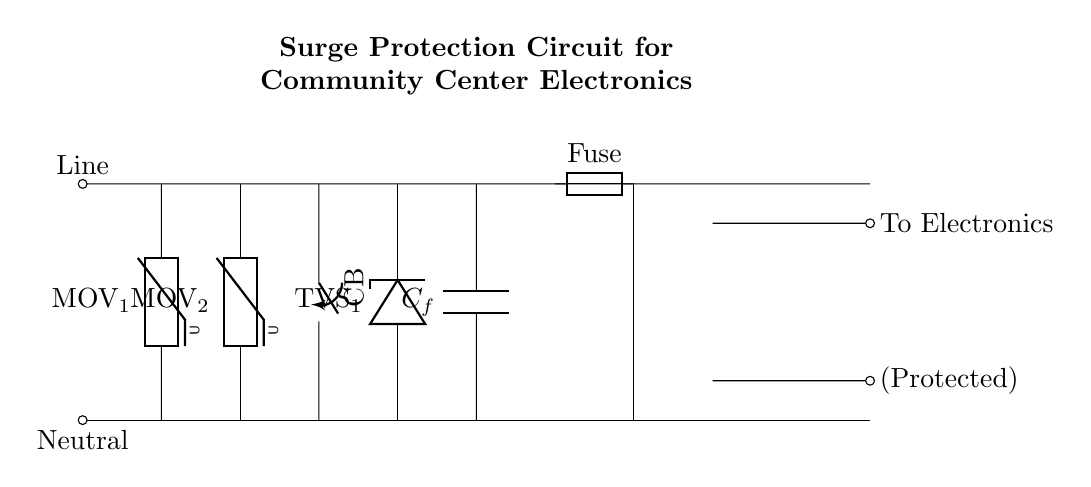What type of surge protection component is used in this circuit? The circuit uses Metal Oxide Varistors (MOVs) for surge protection, visible as MOV_1 and MOV_2 in the diagram.
Answer: Metal Oxide Varistors How many varistors are present in the circuit? There are two varistors, indicated as MOV_1 and MOV_2, shown connected to the power line.
Answer: Two What does CB stand for in this circuit? CB stands for Circuit Breaker, which is a switch placed in the circuit to protect against overloads and short circuits.
Answer: Circuit Breaker What is the purpose of the fuse in this circuit? The fuse serves as a protective device that disconnects the circuit when excessive current flows, preventing damage to the components.
Answer: Disconnects excessive current Which component directly protects against voltage transients? The TVS diode, labeled as TVS_1, is specifically designed to protect against voltage transients by clamping the excess voltage.
Answer: TVS diode How does the transformer function in this circuit? The transformer, shown as a transformer core, steps up or steps down voltage levels, providing appropriate voltage to the protected devices.
Answer: Steps up or steps down voltage What is the function of the filter capacitor in this circuit? The filter capacitor (C_f) smoothens the voltage output by reducing ripple voltage, ensuring a stable current supply to the electronics.
Answer: Smoothens voltage output 